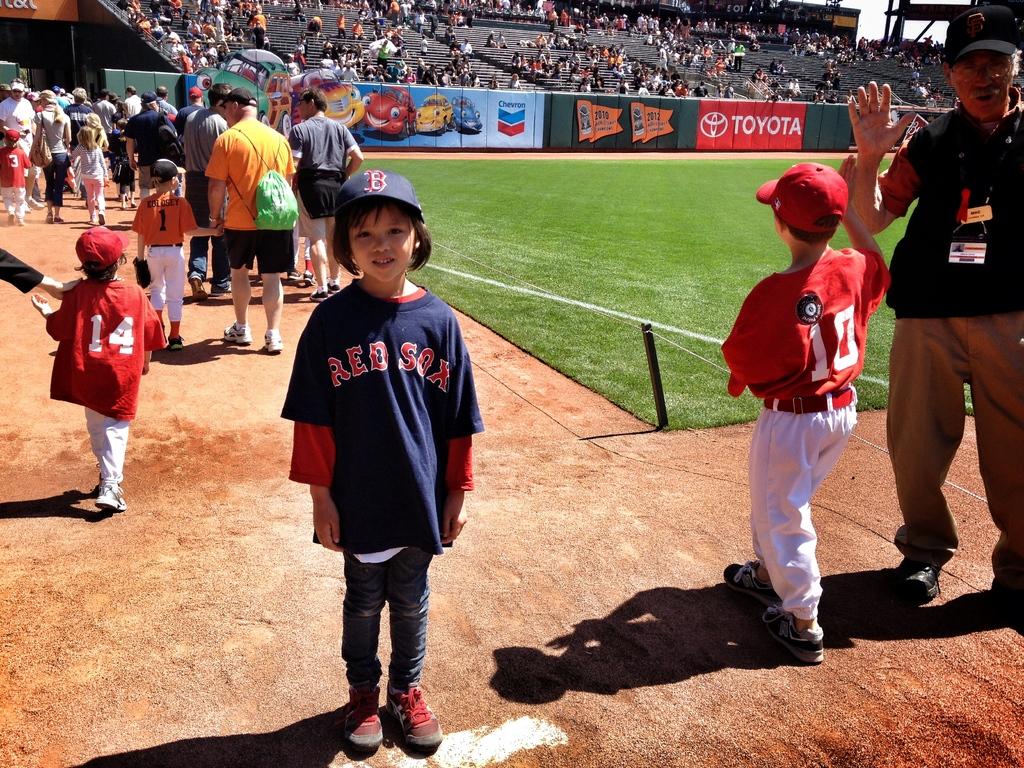What team is on the girls jersey in blue?
Ensure brevity in your answer.  Red sox. 